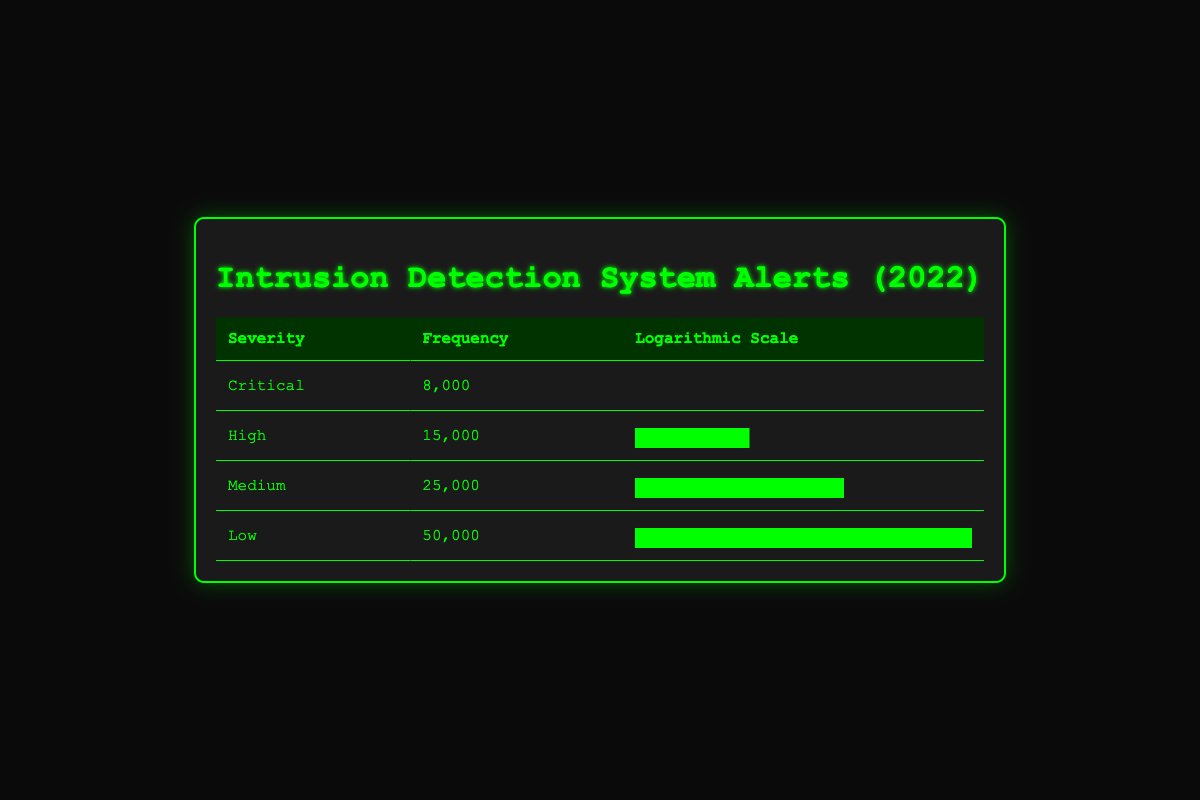What is the frequency of Critical severity alerts? According to the table, the frequency for Critical severity alerts is explicitly listed as 8,000.
Answer: 8,000 What is the highest frequency of alerts recorded? The table shows that the highest frequency of alerts is for Low severity with a frequency of 50,000.
Answer: 50,000 How many more Medium severity alerts are there compared to Critical severity alerts? To find the difference, subtract the frequency of Critical alerts (8,000) from the frequency of Medium alerts (25,000). So, 25,000 - 8,000 = 17,000.
Answer: 17,000 Are there more High severity alerts than Critical severity alerts? The table indicates that High severity alerts have a frequency of 15,000, which is greater than the Critical alerts that have a frequency of 8,000. Thus, the statement is true.
Answer: Yes What is the total frequency of alerts across all severity levels? To find the total frequency, we add up all the individual frequencies: 8,000 + 15,000 + 25,000 + 50,000 = 98,000.
Answer: 98,000 If we consider only the alerts of Medium and Low severity, how much does their combined frequency exceed the frequency of Critical alerts? First, calculate the combined frequency of Medium (25,000) and Low (50,000) alerts: 25,000 + 50,000 = 75,000. Then, subtract the frequency of Critical alerts (8,000) from this combined frequency: 75,000 - 8,000 = 67,000.
Answer: 67,000 What percentage of the total alerts is represented by Low severity alerts? The total frequency of alerts is 98,000. The frequency of Low severity alerts is 50,000. To find the percentage, divide 50,000 by 98,000 and multiply by 100: (50,000 / 98,000) * 100 ≈ 51.02%.
Answer: 51.02% Is the frequency of High severity alerts less than the average frequency of Medium and Low severity alerts? First, calculate the average of Medium (25,000) and Low (50,000): (25,000 + 50,000) / 2 = 37,500. High severity alerts have a frequency of 15,000, which is less than 37,500. Therefore, the statement is true.
Answer: Yes 